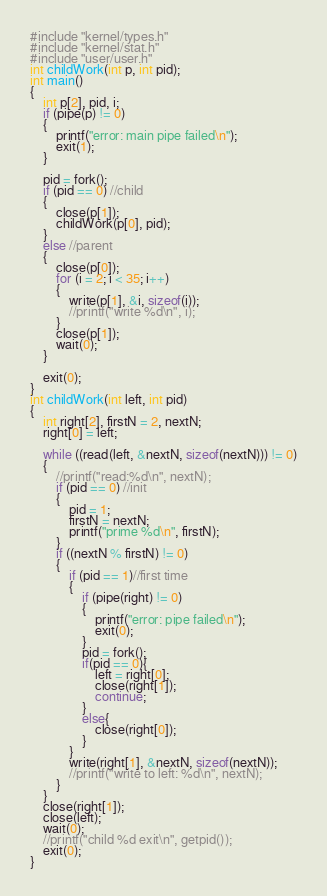<code> <loc_0><loc_0><loc_500><loc_500><_C_>#include "kernel/types.h"
#include "kernel/stat.h"
#include "user/user.h"
int childWork(int p, int pid);
int main()
{
    int p[2], pid, i;
    if (pipe(p) != 0)
    {
        printf("error: main pipe failed\n");
        exit(1);
    }

    pid = fork();
    if (pid == 0) //child
    {
        close(p[1]);
        childWork(p[0], pid);
    }
    else //parent
    {
        close(p[0]);
        for (i = 2; i < 35; i++)
        {
            write(p[1], &i, sizeof(i));
            //printf("write %d\n", i);
        }
        close(p[1]);
        wait(0);
    }

    exit(0);
}
int childWork(int left, int pid)
{
    int right[2], firstN = 2, nextN;
    right[0] = left;

    while ((read(left, &nextN, sizeof(nextN))) != 0)
    {
        //printf("read:%d\n", nextN);
        if (pid == 0) //init
        {
            pid = 1;
            firstN = nextN;
            printf("prime %d\n", firstN);
        }
        if ((nextN % firstN) != 0)
        {
            if (pid == 1)//first time
            {
                if (pipe(right) != 0)
                {
                    printf("error: pipe failed\n");
                    exit(0);
                }
                pid = fork();
                if(pid == 0){
                    left = right[0];
                    close(right[1]);
                    continue;
                }
                else{
                    close(right[0]);
                }
            }
            write(right[1], &nextN, sizeof(nextN));
            //printf("write to left: %d\n", nextN);
        }
    }
    close(right[1]);
    close(left);
    wait(0);
    //printf("child %d exit\n", getpid());
    exit(0);
}
</code> 